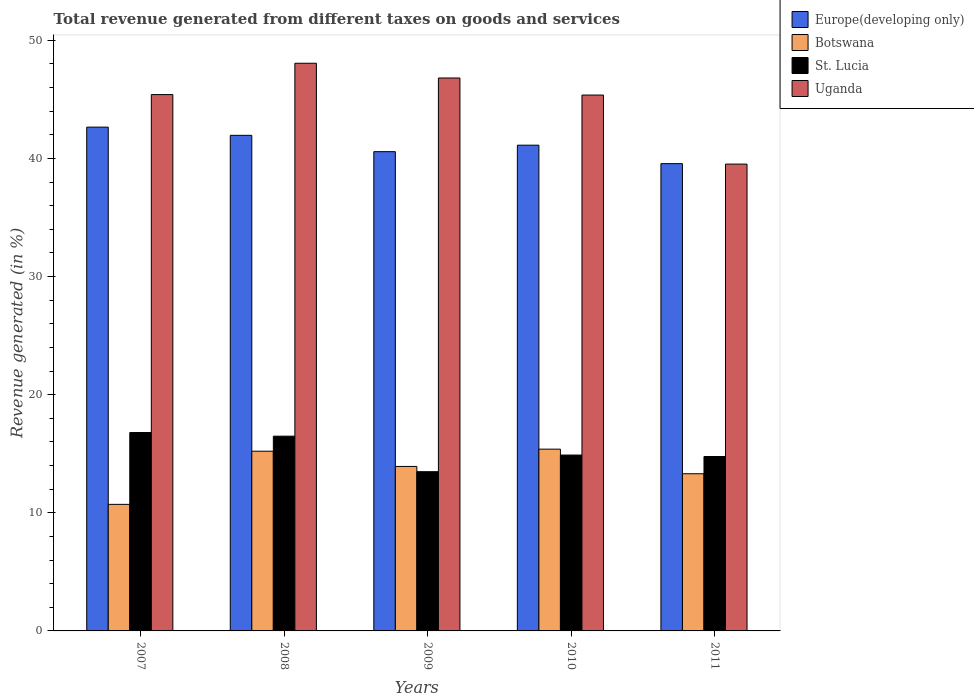How many different coloured bars are there?
Your answer should be very brief. 4. What is the total revenue generated in Uganda in 2007?
Your response must be concise. 45.4. Across all years, what is the maximum total revenue generated in St. Lucia?
Your response must be concise. 16.8. Across all years, what is the minimum total revenue generated in St. Lucia?
Make the answer very short. 13.48. In which year was the total revenue generated in Botswana maximum?
Your response must be concise. 2010. In which year was the total revenue generated in St. Lucia minimum?
Keep it short and to the point. 2009. What is the total total revenue generated in St. Lucia in the graph?
Your answer should be compact. 76.41. What is the difference between the total revenue generated in St. Lucia in 2007 and that in 2009?
Provide a succinct answer. 3.32. What is the difference between the total revenue generated in St. Lucia in 2007 and the total revenue generated in Botswana in 2009?
Provide a short and direct response. 2.87. What is the average total revenue generated in St. Lucia per year?
Ensure brevity in your answer.  15.28. In the year 2010, what is the difference between the total revenue generated in St. Lucia and total revenue generated in Uganda?
Offer a very short reply. -30.48. What is the ratio of the total revenue generated in St. Lucia in 2009 to that in 2010?
Make the answer very short. 0.91. Is the total revenue generated in Botswana in 2008 less than that in 2010?
Offer a terse response. Yes. Is the difference between the total revenue generated in St. Lucia in 2007 and 2008 greater than the difference between the total revenue generated in Uganda in 2007 and 2008?
Keep it short and to the point. Yes. What is the difference between the highest and the second highest total revenue generated in St. Lucia?
Offer a very short reply. 0.31. What is the difference between the highest and the lowest total revenue generated in Europe(developing only)?
Provide a succinct answer. 3.09. What does the 4th bar from the left in 2008 represents?
Your response must be concise. Uganda. What does the 1st bar from the right in 2008 represents?
Your answer should be compact. Uganda. How many years are there in the graph?
Ensure brevity in your answer.  5. What is the difference between two consecutive major ticks on the Y-axis?
Offer a terse response. 10. Does the graph contain any zero values?
Your answer should be compact. No. Where does the legend appear in the graph?
Your answer should be compact. Top right. How many legend labels are there?
Offer a very short reply. 4. What is the title of the graph?
Provide a short and direct response. Total revenue generated from different taxes on goods and services. What is the label or title of the X-axis?
Your response must be concise. Years. What is the label or title of the Y-axis?
Give a very brief answer. Revenue generated (in %). What is the Revenue generated (in %) in Europe(developing only) in 2007?
Give a very brief answer. 42.65. What is the Revenue generated (in %) in Botswana in 2007?
Your answer should be compact. 10.71. What is the Revenue generated (in %) in St. Lucia in 2007?
Your answer should be very brief. 16.8. What is the Revenue generated (in %) in Uganda in 2007?
Provide a succinct answer. 45.4. What is the Revenue generated (in %) of Europe(developing only) in 2008?
Offer a very short reply. 41.95. What is the Revenue generated (in %) in Botswana in 2008?
Your answer should be compact. 15.21. What is the Revenue generated (in %) of St. Lucia in 2008?
Provide a succinct answer. 16.49. What is the Revenue generated (in %) of Uganda in 2008?
Offer a terse response. 48.06. What is the Revenue generated (in %) of Europe(developing only) in 2009?
Your answer should be compact. 40.57. What is the Revenue generated (in %) in Botswana in 2009?
Make the answer very short. 13.92. What is the Revenue generated (in %) of St. Lucia in 2009?
Make the answer very short. 13.48. What is the Revenue generated (in %) in Uganda in 2009?
Keep it short and to the point. 46.81. What is the Revenue generated (in %) in Europe(developing only) in 2010?
Keep it short and to the point. 41.12. What is the Revenue generated (in %) in Botswana in 2010?
Provide a short and direct response. 15.39. What is the Revenue generated (in %) of St. Lucia in 2010?
Your answer should be very brief. 14.89. What is the Revenue generated (in %) of Uganda in 2010?
Give a very brief answer. 45.36. What is the Revenue generated (in %) of Europe(developing only) in 2011?
Give a very brief answer. 39.56. What is the Revenue generated (in %) of Botswana in 2011?
Your answer should be compact. 13.31. What is the Revenue generated (in %) in St. Lucia in 2011?
Provide a short and direct response. 14.77. What is the Revenue generated (in %) of Uganda in 2011?
Your response must be concise. 39.52. Across all years, what is the maximum Revenue generated (in %) of Europe(developing only)?
Offer a terse response. 42.65. Across all years, what is the maximum Revenue generated (in %) in Botswana?
Provide a short and direct response. 15.39. Across all years, what is the maximum Revenue generated (in %) of St. Lucia?
Provide a succinct answer. 16.8. Across all years, what is the maximum Revenue generated (in %) in Uganda?
Make the answer very short. 48.06. Across all years, what is the minimum Revenue generated (in %) in Europe(developing only)?
Ensure brevity in your answer.  39.56. Across all years, what is the minimum Revenue generated (in %) of Botswana?
Keep it short and to the point. 10.71. Across all years, what is the minimum Revenue generated (in %) in St. Lucia?
Provide a short and direct response. 13.48. Across all years, what is the minimum Revenue generated (in %) in Uganda?
Your answer should be very brief. 39.52. What is the total Revenue generated (in %) of Europe(developing only) in the graph?
Provide a succinct answer. 205.85. What is the total Revenue generated (in %) in Botswana in the graph?
Your answer should be compact. 68.54. What is the total Revenue generated (in %) in St. Lucia in the graph?
Provide a short and direct response. 76.41. What is the total Revenue generated (in %) of Uganda in the graph?
Give a very brief answer. 225.15. What is the difference between the Revenue generated (in %) of Europe(developing only) in 2007 and that in 2008?
Your answer should be compact. 0.69. What is the difference between the Revenue generated (in %) in Botswana in 2007 and that in 2008?
Your answer should be compact. -4.5. What is the difference between the Revenue generated (in %) of St. Lucia in 2007 and that in 2008?
Your answer should be compact. 0.31. What is the difference between the Revenue generated (in %) of Uganda in 2007 and that in 2008?
Provide a short and direct response. -2.65. What is the difference between the Revenue generated (in %) of Europe(developing only) in 2007 and that in 2009?
Make the answer very short. 2.08. What is the difference between the Revenue generated (in %) of Botswana in 2007 and that in 2009?
Provide a succinct answer. -3.21. What is the difference between the Revenue generated (in %) in St. Lucia in 2007 and that in 2009?
Your answer should be compact. 3.32. What is the difference between the Revenue generated (in %) of Uganda in 2007 and that in 2009?
Offer a terse response. -1.4. What is the difference between the Revenue generated (in %) in Europe(developing only) in 2007 and that in 2010?
Ensure brevity in your answer.  1.53. What is the difference between the Revenue generated (in %) of Botswana in 2007 and that in 2010?
Provide a succinct answer. -4.68. What is the difference between the Revenue generated (in %) in St. Lucia in 2007 and that in 2010?
Provide a succinct answer. 1.91. What is the difference between the Revenue generated (in %) of Uganda in 2007 and that in 2010?
Make the answer very short. 0.04. What is the difference between the Revenue generated (in %) of Europe(developing only) in 2007 and that in 2011?
Give a very brief answer. 3.09. What is the difference between the Revenue generated (in %) of Botswana in 2007 and that in 2011?
Keep it short and to the point. -2.59. What is the difference between the Revenue generated (in %) of St. Lucia in 2007 and that in 2011?
Give a very brief answer. 2.03. What is the difference between the Revenue generated (in %) in Uganda in 2007 and that in 2011?
Provide a short and direct response. 5.89. What is the difference between the Revenue generated (in %) in Europe(developing only) in 2008 and that in 2009?
Provide a succinct answer. 1.38. What is the difference between the Revenue generated (in %) in Botswana in 2008 and that in 2009?
Make the answer very short. 1.29. What is the difference between the Revenue generated (in %) of St. Lucia in 2008 and that in 2009?
Your answer should be very brief. 3.01. What is the difference between the Revenue generated (in %) of Uganda in 2008 and that in 2009?
Offer a terse response. 1.25. What is the difference between the Revenue generated (in %) in Europe(developing only) in 2008 and that in 2010?
Your response must be concise. 0.83. What is the difference between the Revenue generated (in %) of Botswana in 2008 and that in 2010?
Give a very brief answer. -0.17. What is the difference between the Revenue generated (in %) of St. Lucia in 2008 and that in 2010?
Provide a succinct answer. 1.6. What is the difference between the Revenue generated (in %) in Uganda in 2008 and that in 2010?
Ensure brevity in your answer.  2.69. What is the difference between the Revenue generated (in %) in Europe(developing only) in 2008 and that in 2011?
Offer a very short reply. 2.4. What is the difference between the Revenue generated (in %) in Botswana in 2008 and that in 2011?
Keep it short and to the point. 1.91. What is the difference between the Revenue generated (in %) of St. Lucia in 2008 and that in 2011?
Ensure brevity in your answer.  1.72. What is the difference between the Revenue generated (in %) of Uganda in 2008 and that in 2011?
Make the answer very short. 8.54. What is the difference between the Revenue generated (in %) of Europe(developing only) in 2009 and that in 2010?
Your answer should be compact. -0.55. What is the difference between the Revenue generated (in %) in Botswana in 2009 and that in 2010?
Make the answer very short. -1.46. What is the difference between the Revenue generated (in %) of St. Lucia in 2009 and that in 2010?
Your response must be concise. -1.41. What is the difference between the Revenue generated (in %) in Uganda in 2009 and that in 2010?
Keep it short and to the point. 1.44. What is the difference between the Revenue generated (in %) in Europe(developing only) in 2009 and that in 2011?
Offer a terse response. 1.02. What is the difference between the Revenue generated (in %) of Botswana in 2009 and that in 2011?
Your answer should be compact. 0.62. What is the difference between the Revenue generated (in %) of St. Lucia in 2009 and that in 2011?
Offer a very short reply. -1.29. What is the difference between the Revenue generated (in %) of Uganda in 2009 and that in 2011?
Offer a very short reply. 7.29. What is the difference between the Revenue generated (in %) in Europe(developing only) in 2010 and that in 2011?
Your answer should be very brief. 1.56. What is the difference between the Revenue generated (in %) in Botswana in 2010 and that in 2011?
Your answer should be compact. 2.08. What is the difference between the Revenue generated (in %) in St. Lucia in 2010 and that in 2011?
Give a very brief answer. 0.12. What is the difference between the Revenue generated (in %) of Uganda in 2010 and that in 2011?
Offer a terse response. 5.85. What is the difference between the Revenue generated (in %) of Europe(developing only) in 2007 and the Revenue generated (in %) of Botswana in 2008?
Your answer should be very brief. 27.43. What is the difference between the Revenue generated (in %) of Europe(developing only) in 2007 and the Revenue generated (in %) of St. Lucia in 2008?
Ensure brevity in your answer.  26.16. What is the difference between the Revenue generated (in %) in Europe(developing only) in 2007 and the Revenue generated (in %) in Uganda in 2008?
Your answer should be compact. -5.41. What is the difference between the Revenue generated (in %) in Botswana in 2007 and the Revenue generated (in %) in St. Lucia in 2008?
Make the answer very short. -5.77. What is the difference between the Revenue generated (in %) in Botswana in 2007 and the Revenue generated (in %) in Uganda in 2008?
Your answer should be very brief. -37.34. What is the difference between the Revenue generated (in %) in St. Lucia in 2007 and the Revenue generated (in %) in Uganda in 2008?
Give a very brief answer. -31.26. What is the difference between the Revenue generated (in %) in Europe(developing only) in 2007 and the Revenue generated (in %) in Botswana in 2009?
Your answer should be compact. 28.72. What is the difference between the Revenue generated (in %) of Europe(developing only) in 2007 and the Revenue generated (in %) of St. Lucia in 2009?
Provide a short and direct response. 29.17. What is the difference between the Revenue generated (in %) of Europe(developing only) in 2007 and the Revenue generated (in %) of Uganda in 2009?
Keep it short and to the point. -4.16. What is the difference between the Revenue generated (in %) in Botswana in 2007 and the Revenue generated (in %) in St. Lucia in 2009?
Provide a succinct answer. -2.77. What is the difference between the Revenue generated (in %) of Botswana in 2007 and the Revenue generated (in %) of Uganda in 2009?
Make the answer very short. -36.1. What is the difference between the Revenue generated (in %) of St. Lucia in 2007 and the Revenue generated (in %) of Uganda in 2009?
Your response must be concise. -30.01. What is the difference between the Revenue generated (in %) of Europe(developing only) in 2007 and the Revenue generated (in %) of Botswana in 2010?
Provide a succinct answer. 27.26. What is the difference between the Revenue generated (in %) in Europe(developing only) in 2007 and the Revenue generated (in %) in St. Lucia in 2010?
Provide a succinct answer. 27.76. What is the difference between the Revenue generated (in %) of Europe(developing only) in 2007 and the Revenue generated (in %) of Uganda in 2010?
Give a very brief answer. -2.72. What is the difference between the Revenue generated (in %) in Botswana in 2007 and the Revenue generated (in %) in St. Lucia in 2010?
Give a very brief answer. -4.17. What is the difference between the Revenue generated (in %) of Botswana in 2007 and the Revenue generated (in %) of Uganda in 2010?
Your answer should be very brief. -34.65. What is the difference between the Revenue generated (in %) in St. Lucia in 2007 and the Revenue generated (in %) in Uganda in 2010?
Offer a very short reply. -28.57. What is the difference between the Revenue generated (in %) of Europe(developing only) in 2007 and the Revenue generated (in %) of Botswana in 2011?
Your answer should be compact. 29.34. What is the difference between the Revenue generated (in %) in Europe(developing only) in 2007 and the Revenue generated (in %) in St. Lucia in 2011?
Keep it short and to the point. 27.88. What is the difference between the Revenue generated (in %) in Europe(developing only) in 2007 and the Revenue generated (in %) in Uganda in 2011?
Provide a succinct answer. 3.13. What is the difference between the Revenue generated (in %) in Botswana in 2007 and the Revenue generated (in %) in St. Lucia in 2011?
Ensure brevity in your answer.  -4.05. What is the difference between the Revenue generated (in %) of Botswana in 2007 and the Revenue generated (in %) of Uganda in 2011?
Provide a succinct answer. -28.81. What is the difference between the Revenue generated (in %) of St. Lucia in 2007 and the Revenue generated (in %) of Uganda in 2011?
Offer a terse response. -22.72. What is the difference between the Revenue generated (in %) of Europe(developing only) in 2008 and the Revenue generated (in %) of Botswana in 2009?
Make the answer very short. 28.03. What is the difference between the Revenue generated (in %) in Europe(developing only) in 2008 and the Revenue generated (in %) in St. Lucia in 2009?
Offer a very short reply. 28.48. What is the difference between the Revenue generated (in %) of Europe(developing only) in 2008 and the Revenue generated (in %) of Uganda in 2009?
Give a very brief answer. -4.85. What is the difference between the Revenue generated (in %) of Botswana in 2008 and the Revenue generated (in %) of St. Lucia in 2009?
Give a very brief answer. 1.73. What is the difference between the Revenue generated (in %) of Botswana in 2008 and the Revenue generated (in %) of Uganda in 2009?
Keep it short and to the point. -31.6. What is the difference between the Revenue generated (in %) in St. Lucia in 2008 and the Revenue generated (in %) in Uganda in 2009?
Make the answer very short. -30.32. What is the difference between the Revenue generated (in %) in Europe(developing only) in 2008 and the Revenue generated (in %) in Botswana in 2010?
Provide a succinct answer. 26.57. What is the difference between the Revenue generated (in %) of Europe(developing only) in 2008 and the Revenue generated (in %) of St. Lucia in 2010?
Your answer should be very brief. 27.07. What is the difference between the Revenue generated (in %) in Europe(developing only) in 2008 and the Revenue generated (in %) in Uganda in 2010?
Make the answer very short. -3.41. What is the difference between the Revenue generated (in %) of Botswana in 2008 and the Revenue generated (in %) of St. Lucia in 2010?
Give a very brief answer. 0.33. What is the difference between the Revenue generated (in %) in Botswana in 2008 and the Revenue generated (in %) in Uganda in 2010?
Provide a short and direct response. -30.15. What is the difference between the Revenue generated (in %) of St. Lucia in 2008 and the Revenue generated (in %) of Uganda in 2010?
Ensure brevity in your answer.  -28.88. What is the difference between the Revenue generated (in %) of Europe(developing only) in 2008 and the Revenue generated (in %) of Botswana in 2011?
Your answer should be very brief. 28.65. What is the difference between the Revenue generated (in %) of Europe(developing only) in 2008 and the Revenue generated (in %) of St. Lucia in 2011?
Keep it short and to the point. 27.19. What is the difference between the Revenue generated (in %) of Europe(developing only) in 2008 and the Revenue generated (in %) of Uganda in 2011?
Your response must be concise. 2.44. What is the difference between the Revenue generated (in %) in Botswana in 2008 and the Revenue generated (in %) in St. Lucia in 2011?
Your answer should be very brief. 0.45. What is the difference between the Revenue generated (in %) of Botswana in 2008 and the Revenue generated (in %) of Uganda in 2011?
Your answer should be compact. -24.3. What is the difference between the Revenue generated (in %) in St. Lucia in 2008 and the Revenue generated (in %) in Uganda in 2011?
Your response must be concise. -23.03. What is the difference between the Revenue generated (in %) of Europe(developing only) in 2009 and the Revenue generated (in %) of Botswana in 2010?
Keep it short and to the point. 25.18. What is the difference between the Revenue generated (in %) in Europe(developing only) in 2009 and the Revenue generated (in %) in St. Lucia in 2010?
Give a very brief answer. 25.68. What is the difference between the Revenue generated (in %) in Europe(developing only) in 2009 and the Revenue generated (in %) in Uganda in 2010?
Offer a terse response. -4.79. What is the difference between the Revenue generated (in %) in Botswana in 2009 and the Revenue generated (in %) in St. Lucia in 2010?
Your answer should be very brief. -0.96. What is the difference between the Revenue generated (in %) of Botswana in 2009 and the Revenue generated (in %) of Uganda in 2010?
Your response must be concise. -31.44. What is the difference between the Revenue generated (in %) of St. Lucia in 2009 and the Revenue generated (in %) of Uganda in 2010?
Offer a terse response. -31.88. What is the difference between the Revenue generated (in %) in Europe(developing only) in 2009 and the Revenue generated (in %) in Botswana in 2011?
Your answer should be compact. 27.27. What is the difference between the Revenue generated (in %) in Europe(developing only) in 2009 and the Revenue generated (in %) in St. Lucia in 2011?
Keep it short and to the point. 25.81. What is the difference between the Revenue generated (in %) in Europe(developing only) in 2009 and the Revenue generated (in %) in Uganda in 2011?
Make the answer very short. 1.05. What is the difference between the Revenue generated (in %) of Botswana in 2009 and the Revenue generated (in %) of St. Lucia in 2011?
Your response must be concise. -0.84. What is the difference between the Revenue generated (in %) of Botswana in 2009 and the Revenue generated (in %) of Uganda in 2011?
Keep it short and to the point. -25.6. What is the difference between the Revenue generated (in %) of St. Lucia in 2009 and the Revenue generated (in %) of Uganda in 2011?
Your answer should be very brief. -26.04. What is the difference between the Revenue generated (in %) of Europe(developing only) in 2010 and the Revenue generated (in %) of Botswana in 2011?
Provide a short and direct response. 27.81. What is the difference between the Revenue generated (in %) of Europe(developing only) in 2010 and the Revenue generated (in %) of St. Lucia in 2011?
Make the answer very short. 26.35. What is the difference between the Revenue generated (in %) in Europe(developing only) in 2010 and the Revenue generated (in %) in Uganda in 2011?
Ensure brevity in your answer.  1.6. What is the difference between the Revenue generated (in %) of Botswana in 2010 and the Revenue generated (in %) of St. Lucia in 2011?
Make the answer very short. 0.62. What is the difference between the Revenue generated (in %) of Botswana in 2010 and the Revenue generated (in %) of Uganda in 2011?
Make the answer very short. -24.13. What is the difference between the Revenue generated (in %) of St. Lucia in 2010 and the Revenue generated (in %) of Uganda in 2011?
Your response must be concise. -24.63. What is the average Revenue generated (in %) in Europe(developing only) per year?
Your answer should be compact. 41.17. What is the average Revenue generated (in %) in Botswana per year?
Provide a short and direct response. 13.71. What is the average Revenue generated (in %) in St. Lucia per year?
Provide a succinct answer. 15.28. What is the average Revenue generated (in %) of Uganda per year?
Keep it short and to the point. 45.03. In the year 2007, what is the difference between the Revenue generated (in %) of Europe(developing only) and Revenue generated (in %) of Botswana?
Offer a terse response. 31.94. In the year 2007, what is the difference between the Revenue generated (in %) of Europe(developing only) and Revenue generated (in %) of St. Lucia?
Your answer should be compact. 25.85. In the year 2007, what is the difference between the Revenue generated (in %) in Europe(developing only) and Revenue generated (in %) in Uganda?
Your response must be concise. -2.76. In the year 2007, what is the difference between the Revenue generated (in %) in Botswana and Revenue generated (in %) in St. Lucia?
Your answer should be very brief. -6.08. In the year 2007, what is the difference between the Revenue generated (in %) of Botswana and Revenue generated (in %) of Uganda?
Your answer should be very brief. -34.69. In the year 2007, what is the difference between the Revenue generated (in %) of St. Lucia and Revenue generated (in %) of Uganda?
Provide a short and direct response. -28.61. In the year 2008, what is the difference between the Revenue generated (in %) of Europe(developing only) and Revenue generated (in %) of Botswana?
Your answer should be compact. 26.74. In the year 2008, what is the difference between the Revenue generated (in %) of Europe(developing only) and Revenue generated (in %) of St. Lucia?
Keep it short and to the point. 25.47. In the year 2008, what is the difference between the Revenue generated (in %) of Europe(developing only) and Revenue generated (in %) of Uganda?
Your answer should be compact. -6.1. In the year 2008, what is the difference between the Revenue generated (in %) of Botswana and Revenue generated (in %) of St. Lucia?
Offer a terse response. -1.27. In the year 2008, what is the difference between the Revenue generated (in %) in Botswana and Revenue generated (in %) in Uganda?
Offer a very short reply. -32.84. In the year 2008, what is the difference between the Revenue generated (in %) in St. Lucia and Revenue generated (in %) in Uganda?
Your response must be concise. -31.57. In the year 2009, what is the difference between the Revenue generated (in %) of Europe(developing only) and Revenue generated (in %) of Botswana?
Make the answer very short. 26.65. In the year 2009, what is the difference between the Revenue generated (in %) of Europe(developing only) and Revenue generated (in %) of St. Lucia?
Ensure brevity in your answer.  27.09. In the year 2009, what is the difference between the Revenue generated (in %) of Europe(developing only) and Revenue generated (in %) of Uganda?
Ensure brevity in your answer.  -6.24. In the year 2009, what is the difference between the Revenue generated (in %) of Botswana and Revenue generated (in %) of St. Lucia?
Provide a succinct answer. 0.44. In the year 2009, what is the difference between the Revenue generated (in %) in Botswana and Revenue generated (in %) in Uganda?
Provide a short and direct response. -32.89. In the year 2009, what is the difference between the Revenue generated (in %) of St. Lucia and Revenue generated (in %) of Uganda?
Give a very brief answer. -33.33. In the year 2010, what is the difference between the Revenue generated (in %) of Europe(developing only) and Revenue generated (in %) of Botswana?
Give a very brief answer. 25.73. In the year 2010, what is the difference between the Revenue generated (in %) in Europe(developing only) and Revenue generated (in %) in St. Lucia?
Offer a terse response. 26.23. In the year 2010, what is the difference between the Revenue generated (in %) in Europe(developing only) and Revenue generated (in %) in Uganda?
Your response must be concise. -4.24. In the year 2010, what is the difference between the Revenue generated (in %) of Botswana and Revenue generated (in %) of St. Lucia?
Provide a short and direct response. 0.5. In the year 2010, what is the difference between the Revenue generated (in %) in Botswana and Revenue generated (in %) in Uganda?
Provide a short and direct response. -29.98. In the year 2010, what is the difference between the Revenue generated (in %) of St. Lucia and Revenue generated (in %) of Uganda?
Make the answer very short. -30.48. In the year 2011, what is the difference between the Revenue generated (in %) of Europe(developing only) and Revenue generated (in %) of Botswana?
Your answer should be compact. 26.25. In the year 2011, what is the difference between the Revenue generated (in %) in Europe(developing only) and Revenue generated (in %) in St. Lucia?
Provide a succinct answer. 24.79. In the year 2011, what is the difference between the Revenue generated (in %) in Europe(developing only) and Revenue generated (in %) in Uganda?
Provide a succinct answer. 0.04. In the year 2011, what is the difference between the Revenue generated (in %) of Botswana and Revenue generated (in %) of St. Lucia?
Provide a succinct answer. -1.46. In the year 2011, what is the difference between the Revenue generated (in %) in Botswana and Revenue generated (in %) in Uganda?
Give a very brief answer. -26.21. In the year 2011, what is the difference between the Revenue generated (in %) of St. Lucia and Revenue generated (in %) of Uganda?
Offer a very short reply. -24.75. What is the ratio of the Revenue generated (in %) of Europe(developing only) in 2007 to that in 2008?
Provide a short and direct response. 1.02. What is the ratio of the Revenue generated (in %) in Botswana in 2007 to that in 2008?
Make the answer very short. 0.7. What is the ratio of the Revenue generated (in %) in St. Lucia in 2007 to that in 2008?
Provide a succinct answer. 1.02. What is the ratio of the Revenue generated (in %) in Uganda in 2007 to that in 2008?
Provide a succinct answer. 0.94. What is the ratio of the Revenue generated (in %) in Europe(developing only) in 2007 to that in 2009?
Your answer should be very brief. 1.05. What is the ratio of the Revenue generated (in %) of Botswana in 2007 to that in 2009?
Your answer should be very brief. 0.77. What is the ratio of the Revenue generated (in %) in St. Lucia in 2007 to that in 2009?
Ensure brevity in your answer.  1.25. What is the ratio of the Revenue generated (in %) of Europe(developing only) in 2007 to that in 2010?
Keep it short and to the point. 1.04. What is the ratio of the Revenue generated (in %) in Botswana in 2007 to that in 2010?
Offer a very short reply. 0.7. What is the ratio of the Revenue generated (in %) in St. Lucia in 2007 to that in 2010?
Ensure brevity in your answer.  1.13. What is the ratio of the Revenue generated (in %) of Europe(developing only) in 2007 to that in 2011?
Offer a very short reply. 1.08. What is the ratio of the Revenue generated (in %) of Botswana in 2007 to that in 2011?
Make the answer very short. 0.81. What is the ratio of the Revenue generated (in %) of St. Lucia in 2007 to that in 2011?
Ensure brevity in your answer.  1.14. What is the ratio of the Revenue generated (in %) in Uganda in 2007 to that in 2011?
Offer a terse response. 1.15. What is the ratio of the Revenue generated (in %) in Europe(developing only) in 2008 to that in 2009?
Offer a very short reply. 1.03. What is the ratio of the Revenue generated (in %) of Botswana in 2008 to that in 2009?
Make the answer very short. 1.09. What is the ratio of the Revenue generated (in %) in St. Lucia in 2008 to that in 2009?
Your answer should be very brief. 1.22. What is the ratio of the Revenue generated (in %) of Uganda in 2008 to that in 2009?
Your response must be concise. 1.03. What is the ratio of the Revenue generated (in %) of Europe(developing only) in 2008 to that in 2010?
Keep it short and to the point. 1.02. What is the ratio of the Revenue generated (in %) of Botswana in 2008 to that in 2010?
Ensure brevity in your answer.  0.99. What is the ratio of the Revenue generated (in %) in St. Lucia in 2008 to that in 2010?
Your response must be concise. 1.11. What is the ratio of the Revenue generated (in %) in Uganda in 2008 to that in 2010?
Ensure brevity in your answer.  1.06. What is the ratio of the Revenue generated (in %) in Europe(developing only) in 2008 to that in 2011?
Provide a short and direct response. 1.06. What is the ratio of the Revenue generated (in %) of Botswana in 2008 to that in 2011?
Make the answer very short. 1.14. What is the ratio of the Revenue generated (in %) of St. Lucia in 2008 to that in 2011?
Your response must be concise. 1.12. What is the ratio of the Revenue generated (in %) of Uganda in 2008 to that in 2011?
Your answer should be very brief. 1.22. What is the ratio of the Revenue generated (in %) in Europe(developing only) in 2009 to that in 2010?
Provide a succinct answer. 0.99. What is the ratio of the Revenue generated (in %) in Botswana in 2009 to that in 2010?
Make the answer very short. 0.9. What is the ratio of the Revenue generated (in %) of St. Lucia in 2009 to that in 2010?
Provide a succinct answer. 0.91. What is the ratio of the Revenue generated (in %) in Uganda in 2009 to that in 2010?
Your response must be concise. 1.03. What is the ratio of the Revenue generated (in %) of Europe(developing only) in 2009 to that in 2011?
Your answer should be very brief. 1.03. What is the ratio of the Revenue generated (in %) of Botswana in 2009 to that in 2011?
Make the answer very short. 1.05. What is the ratio of the Revenue generated (in %) of St. Lucia in 2009 to that in 2011?
Give a very brief answer. 0.91. What is the ratio of the Revenue generated (in %) in Uganda in 2009 to that in 2011?
Your answer should be compact. 1.18. What is the ratio of the Revenue generated (in %) in Europe(developing only) in 2010 to that in 2011?
Offer a very short reply. 1.04. What is the ratio of the Revenue generated (in %) in Botswana in 2010 to that in 2011?
Give a very brief answer. 1.16. What is the ratio of the Revenue generated (in %) in St. Lucia in 2010 to that in 2011?
Your answer should be compact. 1.01. What is the ratio of the Revenue generated (in %) in Uganda in 2010 to that in 2011?
Provide a short and direct response. 1.15. What is the difference between the highest and the second highest Revenue generated (in %) in Europe(developing only)?
Your answer should be compact. 0.69. What is the difference between the highest and the second highest Revenue generated (in %) in Botswana?
Offer a very short reply. 0.17. What is the difference between the highest and the second highest Revenue generated (in %) of St. Lucia?
Your answer should be very brief. 0.31. What is the difference between the highest and the second highest Revenue generated (in %) in Uganda?
Your response must be concise. 1.25. What is the difference between the highest and the lowest Revenue generated (in %) in Europe(developing only)?
Give a very brief answer. 3.09. What is the difference between the highest and the lowest Revenue generated (in %) in Botswana?
Provide a short and direct response. 4.68. What is the difference between the highest and the lowest Revenue generated (in %) in St. Lucia?
Ensure brevity in your answer.  3.32. What is the difference between the highest and the lowest Revenue generated (in %) in Uganda?
Your response must be concise. 8.54. 